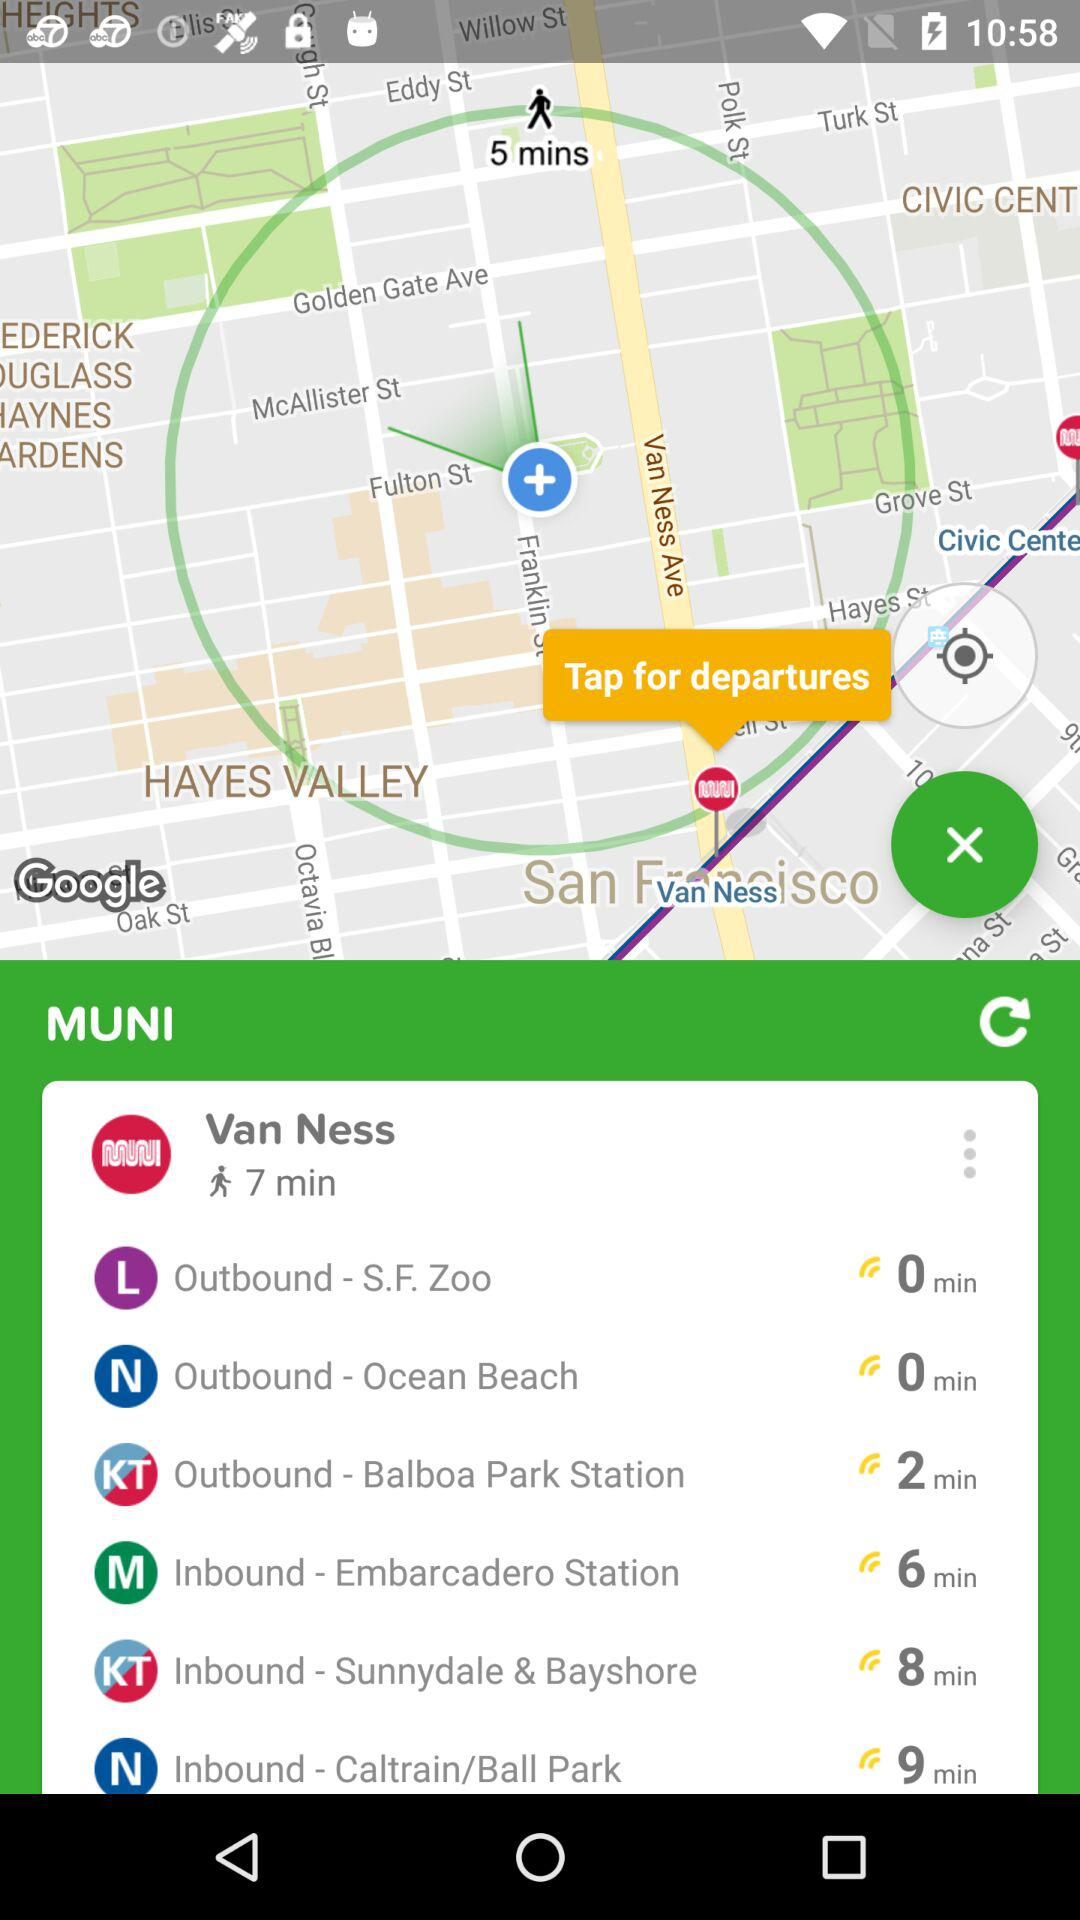How many minutes will it take to go to Inbound-Sunnydale & Bayshore by walking? It will take 8 minutes to walk to Inbound-Sunnydale & Bayshore. 